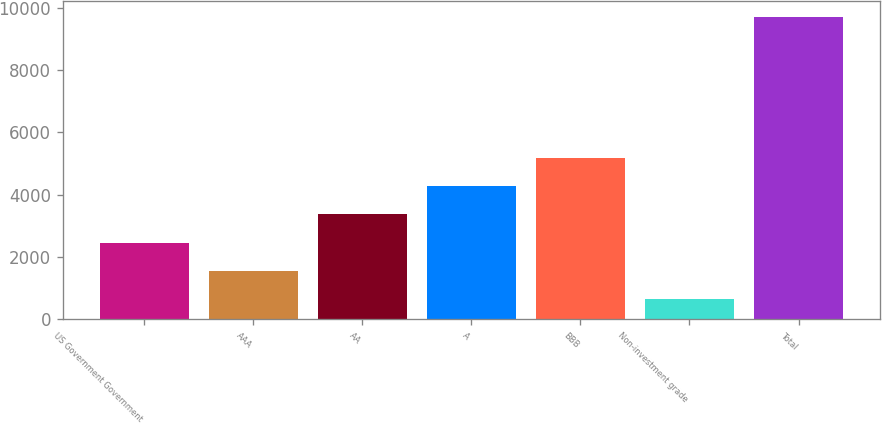Convert chart to OTSL. <chart><loc_0><loc_0><loc_500><loc_500><bar_chart><fcel>US Government Government<fcel>AAA<fcel>AA<fcel>A<fcel>BBB<fcel>Non-investment grade<fcel>Total<nl><fcel>2461<fcel>1554.5<fcel>3367.5<fcel>4274<fcel>5180.5<fcel>648<fcel>9713<nl></chart> 